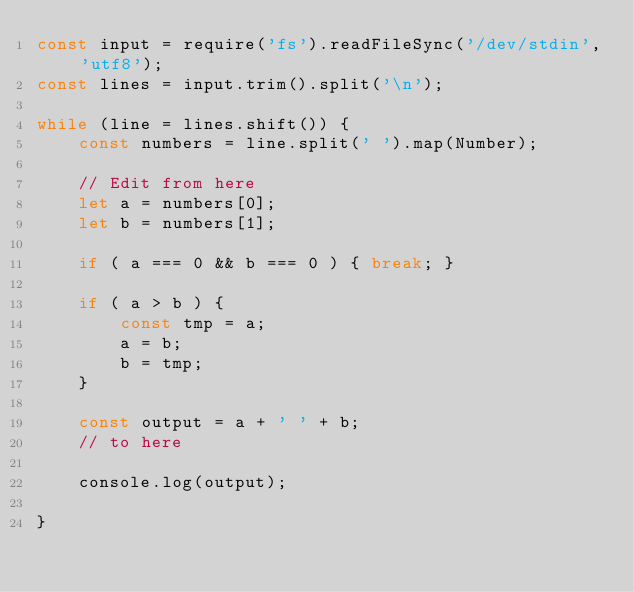Convert code to text. <code><loc_0><loc_0><loc_500><loc_500><_JavaScript_>const input = require('fs').readFileSync('/dev/stdin', 'utf8');
const lines = input.trim().split('\n');

while (line = lines.shift()) {
    const numbers = line.split(' ').map(Number);

    // Edit from here
    let a = numbers[0];
    let b = numbers[1];

    if ( a === 0 && b === 0 ) { break; }

    if ( a > b ) {
        const tmp = a;
        a = b;
        b = tmp;
    } 

    const output = a + ' ' + b;
    // to here
    
    console.log(output);
    
}
</code> 